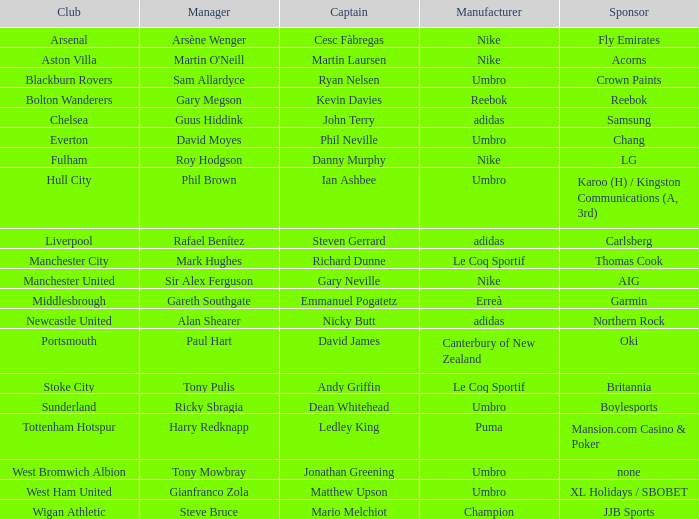Which Manchester United captain is sponsored by Nike? Gary Neville. 